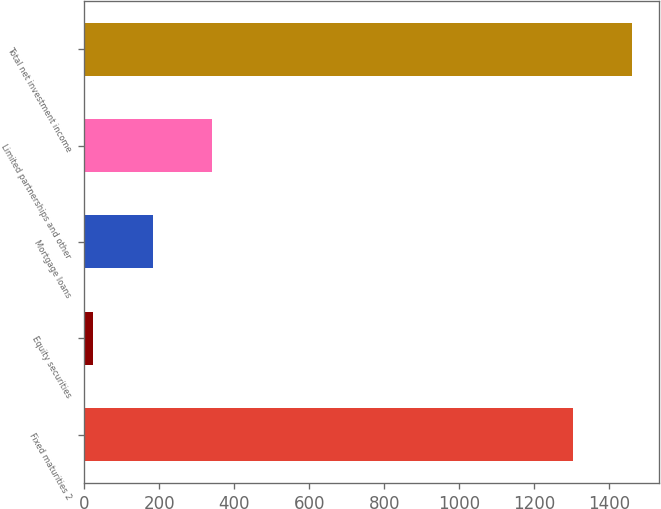<chart> <loc_0><loc_0><loc_500><loc_500><bar_chart><fcel>Fixed maturities 2<fcel>Equity securities<fcel>Mortgage loans<fcel>Limited partnerships and other<fcel>Total net investment income<nl><fcel>1303<fcel>24<fcel>181.9<fcel>339.8<fcel>1460.9<nl></chart> 